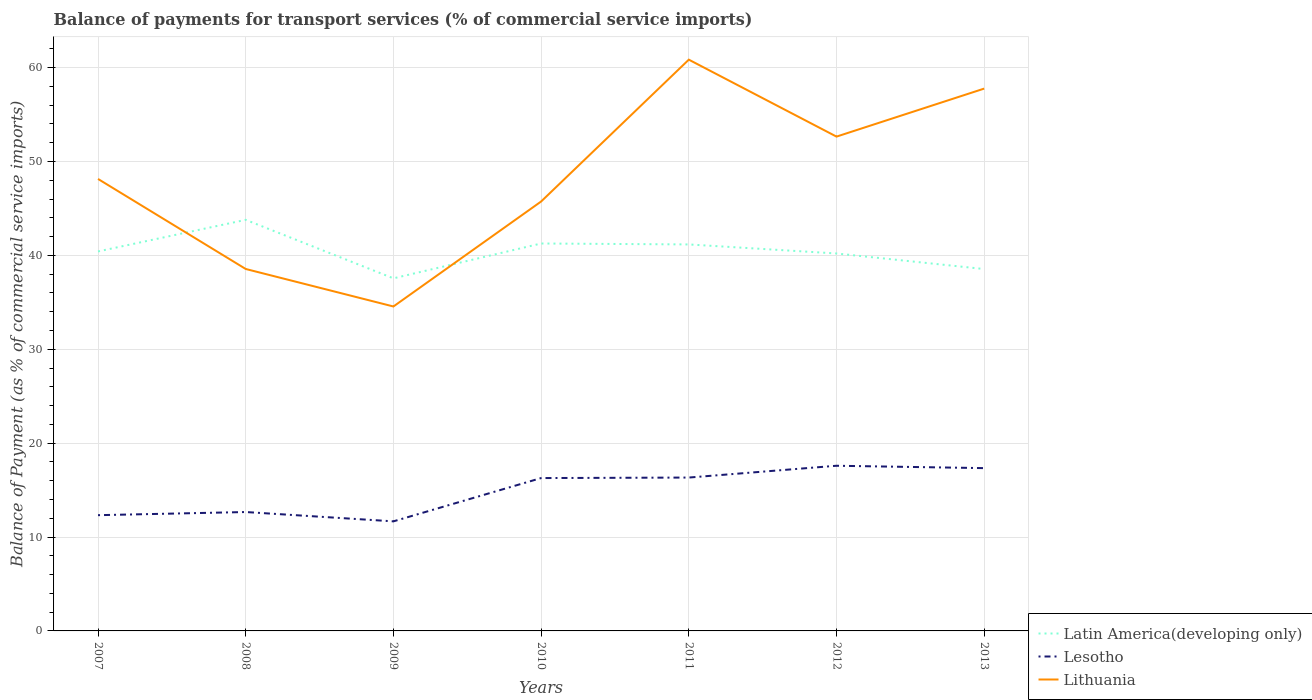How many different coloured lines are there?
Give a very brief answer. 3. Is the number of lines equal to the number of legend labels?
Your answer should be very brief. Yes. Across all years, what is the maximum balance of payments for transport services in Lesotho?
Provide a short and direct response. 11.67. In which year was the balance of payments for transport services in Lithuania maximum?
Provide a short and direct response. 2009. What is the total balance of payments for transport services in Lithuania in the graph?
Offer a terse response. 3.99. What is the difference between the highest and the second highest balance of payments for transport services in Lesotho?
Offer a very short reply. 5.92. How many lines are there?
Your answer should be compact. 3. How many years are there in the graph?
Provide a succinct answer. 7. Are the values on the major ticks of Y-axis written in scientific E-notation?
Keep it short and to the point. No. What is the title of the graph?
Offer a very short reply. Balance of payments for transport services (% of commercial service imports). Does "Gambia, The" appear as one of the legend labels in the graph?
Ensure brevity in your answer.  No. What is the label or title of the X-axis?
Offer a very short reply. Years. What is the label or title of the Y-axis?
Give a very brief answer. Balance of Payment (as % of commercial service imports). What is the Balance of Payment (as % of commercial service imports) in Latin America(developing only) in 2007?
Give a very brief answer. 40.42. What is the Balance of Payment (as % of commercial service imports) in Lesotho in 2007?
Provide a short and direct response. 12.33. What is the Balance of Payment (as % of commercial service imports) of Lithuania in 2007?
Your response must be concise. 48.14. What is the Balance of Payment (as % of commercial service imports) in Latin America(developing only) in 2008?
Your answer should be very brief. 43.79. What is the Balance of Payment (as % of commercial service imports) of Lesotho in 2008?
Offer a terse response. 12.66. What is the Balance of Payment (as % of commercial service imports) in Lithuania in 2008?
Offer a very short reply. 38.55. What is the Balance of Payment (as % of commercial service imports) of Latin America(developing only) in 2009?
Provide a short and direct response. 37.55. What is the Balance of Payment (as % of commercial service imports) of Lesotho in 2009?
Ensure brevity in your answer.  11.67. What is the Balance of Payment (as % of commercial service imports) of Lithuania in 2009?
Offer a very short reply. 34.56. What is the Balance of Payment (as % of commercial service imports) of Latin America(developing only) in 2010?
Make the answer very short. 41.27. What is the Balance of Payment (as % of commercial service imports) of Lesotho in 2010?
Provide a short and direct response. 16.28. What is the Balance of Payment (as % of commercial service imports) in Lithuania in 2010?
Offer a terse response. 45.74. What is the Balance of Payment (as % of commercial service imports) in Latin America(developing only) in 2011?
Your response must be concise. 41.17. What is the Balance of Payment (as % of commercial service imports) of Lesotho in 2011?
Give a very brief answer. 16.34. What is the Balance of Payment (as % of commercial service imports) of Lithuania in 2011?
Provide a succinct answer. 60.85. What is the Balance of Payment (as % of commercial service imports) of Latin America(developing only) in 2012?
Give a very brief answer. 40.2. What is the Balance of Payment (as % of commercial service imports) in Lesotho in 2012?
Give a very brief answer. 17.59. What is the Balance of Payment (as % of commercial service imports) in Lithuania in 2012?
Offer a very short reply. 52.65. What is the Balance of Payment (as % of commercial service imports) of Latin America(developing only) in 2013?
Your answer should be compact. 38.54. What is the Balance of Payment (as % of commercial service imports) of Lesotho in 2013?
Ensure brevity in your answer.  17.34. What is the Balance of Payment (as % of commercial service imports) of Lithuania in 2013?
Keep it short and to the point. 57.77. Across all years, what is the maximum Balance of Payment (as % of commercial service imports) in Latin America(developing only)?
Give a very brief answer. 43.79. Across all years, what is the maximum Balance of Payment (as % of commercial service imports) in Lesotho?
Make the answer very short. 17.59. Across all years, what is the maximum Balance of Payment (as % of commercial service imports) of Lithuania?
Provide a succinct answer. 60.85. Across all years, what is the minimum Balance of Payment (as % of commercial service imports) in Latin America(developing only)?
Give a very brief answer. 37.55. Across all years, what is the minimum Balance of Payment (as % of commercial service imports) of Lesotho?
Make the answer very short. 11.67. Across all years, what is the minimum Balance of Payment (as % of commercial service imports) in Lithuania?
Your response must be concise. 34.56. What is the total Balance of Payment (as % of commercial service imports) of Latin America(developing only) in the graph?
Your answer should be very brief. 282.94. What is the total Balance of Payment (as % of commercial service imports) in Lesotho in the graph?
Offer a terse response. 104.21. What is the total Balance of Payment (as % of commercial service imports) in Lithuania in the graph?
Your answer should be very brief. 338.26. What is the difference between the Balance of Payment (as % of commercial service imports) in Latin America(developing only) in 2007 and that in 2008?
Your answer should be very brief. -3.37. What is the difference between the Balance of Payment (as % of commercial service imports) of Lesotho in 2007 and that in 2008?
Your response must be concise. -0.34. What is the difference between the Balance of Payment (as % of commercial service imports) of Lithuania in 2007 and that in 2008?
Provide a succinct answer. 9.59. What is the difference between the Balance of Payment (as % of commercial service imports) of Latin America(developing only) in 2007 and that in 2009?
Offer a terse response. 2.87. What is the difference between the Balance of Payment (as % of commercial service imports) of Lesotho in 2007 and that in 2009?
Keep it short and to the point. 0.66. What is the difference between the Balance of Payment (as % of commercial service imports) of Lithuania in 2007 and that in 2009?
Your answer should be compact. 13.59. What is the difference between the Balance of Payment (as % of commercial service imports) of Latin America(developing only) in 2007 and that in 2010?
Offer a very short reply. -0.85. What is the difference between the Balance of Payment (as % of commercial service imports) of Lesotho in 2007 and that in 2010?
Give a very brief answer. -3.95. What is the difference between the Balance of Payment (as % of commercial service imports) of Lithuania in 2007 and that in 2010?
Your response must be concise. 2.4. What is the difference between the Balance of Payment (as % of commercial service imports) in Latin America(developing only) in 2007 and that in 2011?
Your answer should be very brief. -0.75. What is the difference between the Balance of Payment (as % of commercial service imports) in Lesotho in 2007 and that in 2011?
Provide a succinct answer. -4.01. What is the difference between the Balance of Payment (as % of commercial service imports) in Lithuania in 2007 and that in 2011?
Keep it short and to the point. -12.71. What is the difference between the Balance of Payment (as % of commercial service imports) in Latin America(developing only) in 2007 and that in 2012?
Your response must be concise. 0.22. What is the difference between the Balance of Payment (as % of commercial service imports) of Lesotho in 2007 and that in 2012?
Your answer should be compact. -5.26. What is the difference between the Balance of Payment (as % of commercial service imports) of Lithuania in 2007 and that in 2012?
Offer a very short reply. -4.51. What is the difference between the Balance of Payment (as % of commercial service imports) in Latin America(developing only) in 2007 and that in 2013?
Provide a short and direct response. 1.88. What is the difference between the Balance of Payment (as % of commercial service imports) of Lesotho in 2007 and that in 2013?
Make the answer very short. -5.01. What is the difference between the Balance of Payment (as % of commercial service imports) of Lithuania in 2007 and that in 2013?
Your response must be concise. -9.62. What is the difference between the Balance of Payment (as % of commercial service imports) in Latin America(developing only) in 2008 and that in 2009?
Provide a succinct answer. 6.23. What is the difference between the Balance of Payment (as % of commercial service imports) in Lesotho in 2008 and that in 2009?
Provide a short and direct response. 0.99. What is the difference between the Balance of Payment (as % of commercial service imports) in Lithuania in 2008 and that in 2009?
Your response must be concise. 3.99. What is the difference between the Balance of Payment (as % of commercial service imports) of Latin America(developing only) in 2008 and that in 2010?
Your answer should be compact. 2.52. What is the difference between the Balance of Payment (as % of commercial service imports) in Lesotho in 2008 and that in 2010?
Make the answer very short. -3.62. What is the difference between the Balance of Payment (as % of commercial service imports) of Lithuania in 2008 and that in 2010?
Offer a terse response. -7.19. What is the difference between the Balance of Payment (as % of commercial service imports) of Latin America(developing only) in 2008 and that in 2011?
Provide a succinct answer. 2.62. What is the difference between the Balance of Payment (as % of commercial service imports) in Lesotho in 2008 and that in 2011?
Provide a short and direct response. -3.67. What is the difference between the Balance of Payment (as % of commercial service imports) in Lithuania in 2008 and that in 2011?
Provide a succinct answer. -22.3. What is the difference between the Balance of Payment (as % of commercial service imports) of Latin America(developing only) in 2008 and that in 2012?
Offer a very short reply. 3.58. What is the difference between the Balance of Payment (as % of commercial service imports) in Lesotho in 2008 and that in 2012?
Make the answer very short. -4.93. What is the difference between the Balance of Payment (as % of commercial service imports) in Lithuania in 2008 and that in 2012?
Offer a very short reply. -14.1. What is the difference between the Balance of Payment (as % of commercial service imports) of Latin America(developing only) in 2008 and that in 2013?
Your answer should be very brief. 5.24. What is the difference between the Balance of Payment (as % of commercial service imports) in Lesotho in 2008 and that in 2013?
Offer a terse response. -4.68. What is the difference between the Balance of Payment (as % of commercial service imports) in Lithuania in 2008 and that in 2013?
Ensure brevity in your answer.  -19.21. What is the difference between the Balance of Payment (as % of commercial service imports) in Latin America(developing only) in 2009 and that in 2010?
Ensure brevity in your answer.  -3.71. What is the difference between the Balance of Payment (as % of commercial service imports) in Lesotho in 2009 and that in 2010?
Your response must be concise. -4.61. What is the difference between the Balance of Payment (as % of commercial service imports) of Lithuania in 2009 and that in 2010?
Keep it short and to the point. -11.18. What is the difference between the Balance of Payment (as % of commercial service imports) in Latin America(developing only) in 2009 and that in 2011?
Ensure brevity in your answer.  -3.61. What is the difference between the Balance of Payment (as % of commercial service imports) in Lesotho in 2009 and that in 2011?
Your response must be concise. -4.67. What is the difference between the Balance of Payment (as % of commercial service imports) in Lithuania in 2009 and that in 2011?
Provide a succinct answer. -26.29. What is the difference between the Balance of Payment (as % of commercial service imports) of Latin America(developing only) in 2009 and that in 2012?
Provide a succinct answer. -2.65. What is the difference between the Balance of Payment (as % of commercial service imports) in Lesotho in 2009 and that in 2012?
Offer a terse response. -5.92. What is the difference between the Balance of Payment (as % of commercial service imports) of Lithuania in 2009 and that in 2012?
Give a very brief answer. -18.09. What is the difference between the Balance of Payment (as % of commercial service imports) in Latin America(developing only) in 2009 and that in 2013?
Offer a terse response. -0.99. What is the difference between the Balance of Payment (as % of commercial service imports) in Lesotho in 2009 and that in 2013?
Your answer should be very brief. -5.67. What is the difference between the Balance of Payment (as % of commercial service imports) of Lithuania in 2009 and that in 2013?
Your answer should be very brief. -23.21. What is the difference between the Balance of Payment (as % of commercial service imports) in Latin America(developing only) in 2010 and that in 2011?
Provide a short and direct response. 0.1. What is the difference between the Balance of Payment (as % of commercial service imports) in Lesotho in 2010 and that in 2011?
Your answer should be compact. -0.05. What is the difference between the Balance of Payment (as % of commercial service imports) in Lithuania in 2010 and that in 2011?
Offer a very short reply. -15.11. What is the difference between the Balance of Payment (as % of commercial service imports) in Latin America(developing only) in 2010 and that in 2012?
Provide a short and direct response. 1.06. What is the difference between the Balance of Payment (as % of commercial service imports) of Lesotho in 2010 and that in 2012?
Offer a very short reply. -1.31. What is the difference between the Balance of Payment (as % of commercial service imports) in Lithuania in 2010 and that in 2012?
Make the answer very short. -6.91. What is the difference between the Balance of Payment (as % of commercial service imports) of Latin America(developing only) in 2010 and that in 2013?
Ensure brevity in your answer.  2.72. What is the difference between the Balance of Payment (as % of commercial service imports) of Lesotho in 2010 and that in 2013?
Keep it short and to the point. -1.06. What is the difference between the Balance of Payment (as % of commercial service imports) of Lithuania in 2010 and that in 2013?
Ensure brevity in your answer.  -12.03. What is the difference between the Balance of Payment (as % of commercial service imports) of Lesotho in 2011 and that in 2012?
Provide a succinct answer. -1.26. What is the difference between the Balance of Payment (as % of commercial service imports) of Lithuania in 2011 and that in 2012?
Your answer should be compact. 8.2. What is the difference between the Balance of Payment (as % of commercial service imports) in Latin America(developing only) in 2011 and that in 2013?
Provide a succinct answer. 2.62. What is the difference between the Balance of Payment (as % of commercial service imports) in Lesotho in 2011 and that in 2013?
Offer a terse response. -1. What is the difference between the Balance of Payment (as % of commercial service imports) in Lithuania in 2011 and that in 2013?
Provide a short and direct response. 3.08. What is the difference between the Balance of Payment (as % of commercial service imports) of Latin America(developing only) in 2012 and that in 2013?
Ensure brevity in your answer.  1.66. What is the difference between the Balance of Payment (as % of commercial service imports) of Lesotho in 2012 and that in 2013?
Provide a short and direct response. 0.25. What is the difference between the Balance of Payment (as % of commercial service imports) of Lithuania in 2012 and that in 2013?
Your answer should be very brief. -5.11. What is the difference between the Balance of Payment (as % of commercial service imports) of Latin America(developing only) in 2007 and the Balance of Payment (as % of commercial service imports) of Lesotho in 2008?
Offer a very short reply. 27.76. What is the difference between the Balance of Payment (as % of commercial service imports) in Latin America(developing only) in 2007 and the Balance of Payment (as % of commercial service imports) in Lithuania in 2008?
Your response must be concise. 1.87. What is the difference between the Balance of Payment (as % of commercial service imports) in Lesotho in 2007 and the Balance of Payment (as % of commercial service imports) in Lithuania in 2008?
Keep it short and to the point. -26.22. What is the difference between the Balance of Payment (as % of commercial service imports) in Latin America(developing only) in 2007 and the Balance of Payment (as % of commercial service imports) in Lesotho in 2009?
Keep it short and to the point. 28.75. What is the difference between the Balance of Payment (as % of commercial service imports) of Latin America(developing only) in 2007 and the Balance of Payment (as % of commercial service imports) of Lithuania in 2009?
Keep it short and to the point. 5.86. What is the difference between the Balance of Payment (as % of commercial service imports) of Lesotho in 2007 and the Balance of Payment (as % of commercial service imports) of Lithuania in 2009?
Give a very brief answer. -22.23. What is the difference between the Balance of Payment (as % of commercial service imports) in Latin America(developing only) in 2007 and the Balance of Payment (as % of commercial service imports) in Lesotho in 2010?
Ensure brevity in your answer.  24.14. What is the difference between the Balance of Payment (as % of commercial service imports) of Latin America(developing only) in 2007 and the Balance of Payment (as % of commercial service imports) of Lithuania in 2010?
Provide a short and direct response. -5.32. What is the difference between the Balance of Payment (as % of commercial service imports) of Lesotho in 2007 and the Balance of Payment (as % of commercial service imports) of Lithuania in 2010?
Ensure brevity in your answer.  -33.41. What is the difference between the Balance of Payment (as % of commercial service imports) of Latin America(developing only) in 2007 and the Balance of Payment (as % of commercial service imports) of Lesotho in 2011?
Provide a succinct answer. 24.08. What is the difference between the Balance of Payment (as % of commercial service imports) in Latin America(developing only) in 2007 and the Balance of Payment (as % of commercial service imports) in Lithuania in 2011?
Make the answer very short. -20.43. What is the difference between the Balance of Payment (as % of commercial service imports) of Lesotho in 2007 and the Balance of Payment (as % of commercial service imports) of Lithuania in 2011?
Offer a very short reply. -48.52. What is the difference between the Balance of Payment (as % of commercial service imports) of Latin America(developing only) in 2007 and the Balance of Payment (as % of commercial service imports) of Lesotho in 2012?
Make the answer very short. 22.83. What is the difference between the Balance of Payment (as % of commercial service imports) in Latin America(developing only) in 2007 and the Balance of Payment (as % of commercial service imports) in Lithuania in 2012?
Keep it short and to the point. -12.23. What is the difference between the Balance of Payment (as % of commercial service imports) of Lesotho in 2007 and the Balance of Payment (as % of commercial service imports) of Lithuania in 2012?
Ensure brevity in your answer.  -40.32. What is the difference between the Balance of Payment (as % of commercial service imports) in Latin America(developing only) in 2007 and the Balance of Payment (as % of commercial service imports) in Lesotho in 2013?
Offer a very short reply. 23.08. What is the difference between the Balance of Payment (as % of commercial service imports) of Latin America(developing only) in 2007 and the Balance of Payment (as % of commercial service imports) of Lithuania in 2013?
Keep it short and to the point. -17.35. What is the difference between the Balance of Payment (as % of commercial service imports) of Lesotho in 2007 and the Balance of Payment (as % of commercial service imports) of Lithuania in 2013?
Ensure brevity in your answer.  -45.44. What is the difference between the Balance of Payment (as % of commercial service imports) in Latin America(developing only) in 2008 and the Balance of Payment (as % of commercial service imports) in Lesotho in 2009?
Provide a short and direct response. 32.12. What is the difference between the Balance of Payment (as % of commercial service imports) in Latin America(developing only) in 2008 and the Balance of Payment (as % of commercial service imports) in Lithuania in 2009?
Ensure brevity in your answer.  9.23. What is the difference between the Balance of Payment (as % of commercial service imports) in Lesotho in 2008 and the Balance of Payment (as % of commercial service imports) in Lithuania in 2009?
Give a very brief answer. -21.89. What is the difference between the Balance of Payment (as % of commercial service imports) in Latin America(developing only) in 2008 and the Balance of Payment (as % of commercial service imports) in Lesotho in 2010?
Your answer should be very brief. 27.5. What is the difference between the Balance of Payment (as % of commercial service imports) in Latin America(developing only) in 2008 and the Balance of Payment (as % of commercial service imports) in Lithuania in 2010?
Your response must be concise. -1.95. What is the difference between the Balance of Payment (as % of commercial service imports) in Lesotho in 2008 and the Balance of Payment (as % of commercial service imports) in Lithuania in 2010?
Keep it short and to the point. -33.08. What is the difference between the Balance of Payment (as % of commercial service imports) in Latin America(developing only) in 2008 and the Balance of Payment (as % of commercial service imports) in Lesotho in 2011?
Your answer should be very brief. 27.45. What is the difference between the Balance of Payment (as % of commercial service imports) in Latin America(developing only) in 2008 and the Balance of Payment (as % of commercial service imports) in Lithuania in 2011?
Provide a short and direct response. -17.06. What is the difference between the Balance of Payment (as % of commercial service imports) in Lesotho in 2008 and the Balance of Payment (as % of commercial service imports) in Lithuania in 2011?
Your answer should be very brief. -48.18. What is the difference between the Balance of Payment (as % of commercial service imports) of Latin America(developing only) in 2008 and the Balance of Payment (as % of commercial service imports) of Lesotho in 2012?
Provide a succinct answer. 26.19. What is the difference between the Balance of Payment (as % of commercial service imports) in Latin America(developing only) in 2008 and the Balance of Payment (as % of commercial service imports) in Lithuania in 2012?
Your answer should be very brief. -8.87. What is the difference between the Balance of Payment (as % of commercial service imports) of Lesotho in 2008 and the Balance of Payment (as % of commercial service imports) of Lithuania in 2012?
Give a very brief answer. -39.99. What is the difference between the Balance of Payment (as % of commercial service imports) of Latin America(developing only) in 2008 and the Balance of Payment (as % of commercial service imports) of Lesotho in 2013?
Your response must be concise. 26.45. What is the difference between the Balance of Payment (as % of commercial service imports) in Latin America(developing only) in 2008 and the Balance of Payment (as % of commercial service imports) in Lithuania in 2013?
Offer a terse response. -13.98. What is the difference between the Balance of Payment (as % of commercial service imports) in Lesotho in 2008 and the Balance of Payment (as % of commercial service imports) in Lithuania in 2013?
Your answer should be very brief. -45.1. What is the difference between the Balance of Payment (as % of commercial service imports) in Latin America(developing only) in 2009 and the Balance of Payment (as % of commercial service imports) in Lesotho in 2010?
Provide a succinct answer. 21.27. What is the difference between the Balance of Payment (as % of commercial service imports) in Latin America(developing only) in 2009 and the Balance of Payment (as % of commercial service imports) in Lithuania in 2010?
Make the answer very short. -8.18. What is the difference between the Balance of Payment (as % of commercial service imports) in Lesotho in 2009 and the Balance of Payment (as % of commercial service imports) in Lithuania in 2010?
Offer a very short reply. -34.07. What is the difference between the Balance of Payment (as % of commercial service imports) of Latin America(developing only) in 2009 and the Balance of Payment (as % of commercial service imports) of Lesotho in 2011?
Provide a succinct answer. 21.22. What is the difference between the Balance of Payment (as % of commercial service imports) of Latin America(developing only) in 2009 and the Balance of Payment (as % of commercial service imports) of Lithuania in 2011?
Offer a very short reply. -23.29. What is the difference between the Balance of Payment (as % of commercial service imports) in Lesotho in 2009 and the Balance of Payment (as % of commercial service imports) in Lithuania in 2011?
Provide a short and direct response. -49.18. What is the difference between the Balance of Payment (as % of commercial service imports) in Latin America(developing only) in 2009 and the Balance of Payment (as % of commercial service imports) in Lesotho in 2012?
Provide a succinct answer. 19.96. What is the difference between the Balance of Payment (as % of commercial service imports) of Latin America(developing only) in 2009 and the Balance of Payment (as % of commercial service imports) of Lithuania in 2012?
Offer a very short reply. -15.1. What is the difference between the Balance of Payment (as % of commercial service imports) in Lesotho in 2009 and the Balance of Payment (as % of commercial service imports) in Lithuania in 2012?
Your answer should be compact. -40.98. What is the difference between the Balance of Payment (as % of commercial service imports) in Latin America(developing only) in 2009 and the Balance of Payment (as % of commercial service imports) in Lesotho in 2013?
Your response must be concise. 20.21. What is the difference between the Balance of Payment (as % of commercial service imports) in Latin America(developing only) in 2009 and the Balance of Payment (as % of commercial service imports) in Lithuania in 2013?
Make the answer very short. -20.21. What is the difference between the Balance of Payment (as % of commercial service imports) in Lesotho in 2009 and the Balance of Payment (as % of commercial service imports) in Lithuania in 2013?
Your answer should be very brief. -46.1. What is the difference between the Balance of Payment (as % of commercial service imports) in Latin America(developing only) in 2010 and the Balance of Payment (as % of commercial service imports) in Lesotho in 2011?
Keep it short and to the point. 24.93. What is the difference between the Balance of Payment (as % of commercial service imports) in Latin America(developing only) in 2010 and the Balance of Payment (as % of commercial service imports) in Lithuania in 2011?
Offer a terse response. -19.58. What is the difference between the Balance of Payment (as % of commercial service imports) of Lesotho in 2010 and the Balance of Payment (as % of commercial service imports) of Lithuania in 2011?
Offer a very short reply. -44.57. What is the difference between the Balance of Payment (as % of commercial service imports) of Latin America(developing only) in 2010 and the Balance of Payment (as % of commercial service imports) of Lesotho in 2012?
Provide a short and direct response. 23.67. What is the difference between the Balance of Payment (as % of commercial service imports) in Latin America(developing only) in 2010 and the Balance of Payment (as % of commercial service imports) in Lithuania in 2012?
Your response must be concise. -11.38. What is the difference between the Balance of Payment (as % of commercial service imports) in Lesotho in 2010 and the Balance of Payment (as % of commercial service imports) in Lithuania in 2012?
Provide a succinct answer. -36.37. What is the difference between the Balance of Payment (as % of commercial service imports) of Latin America(developing only) in 2010 and the Balance of Payment (as % of commercial service imports) of Lesotho in 2013?
Your answer should be compact. 23.93. What is the difference between the Balance of Payment (as % of commercial service imports) in Latin America(developing only) in 2010 and the Balance of Payment (as % of commercial service imports) in Lithuania in 2013?
Make the answer very short. -16.5. What is the difference between the Balance of Payment (as % of commercial service imports) in Lesotho in 2010 and the Balance of Payment (as % of commercial service imports) in Lithuania in 2013?
Make the answer very short. -41.48. What is the difference between the Balance of Payment (as % of commercial service imports) in Latin America(developing only) in 2011 and the Balance of Payment (as % of commercial service imports) in Lesotho in 2012?
Offer a terse response. 23.57. What is the difference between the Balance of Payment (as % of commercial service imports) of Latin America(developing only) in 2011 and the Balance of Payment (as % of commercial service imports) of Lithuania in 2012?
Your response must be concise. -11.49. What is the difference between the Balance of Payment (as % of commercial service imports) in Lesotho in 2011 and the Balance of Payment (as % of commercial service imports) in Lithuania in 2012?
Your response must be concise. -36.32. What is the difference between the Balance of Payment (as % of commercial service imports) in Latin America(developing only) in 2011 and the Balance of Payment (as % of commercial service imports) in Lesotho in 2013?
Keep it short and to the point. 23.83. What is the difference between the Balance of Payment (as % of commercial service imports) of Latin America(developing only) in 2011 and the Balance of Payment (as % of commercial service imports) of Lithuania in 2013?
Your answer should be compact. -16.6. What is the difference between the Balance of Payment (as % of commercial service imports) of Lesotho in 2011 and the Balance of Payment (as % of commercial service imports) of Lithuania in 2013?
Make the answer very short. -41.43. What is the difference between the Balance of Payment (as % of commercial service imports) of Latin America(developing only) in 2012 and the Balance of Payment (as % of commercial service imports) of Lesotho in 2013?
Provide a short and direct response. 22.86. What is the difference between the Balance of Payment (as % of commercial service imports) of Latin America(developing only) in 2012 and the Balance of Payment (as % of commercial service imports) of Lithuania in 2013?
Ensure brevity in your answer.  -17.56. What is the difference between the Balance of Payment (as % of commercial service imports) in Lesotho in 2012 and the Balance of Payment (as % of commercial service imports) in Lithuania in 2013?
Give a very brief answer. -40.17. What is the average Balance of Payment (as % of commercial service imports) of Latin America(developing only) per year?
Offer a terse response. 40.42. What is the average Balance of Payment (as % of commercial service imports) in Lesotho per year?
Provide a short and direct response. 14.89. What is the average Balance of Payment (as % of commercial service imports) of Lithuania per year?
Offer a terse response. 48.32. In the year 2007, what is the difference between the Balance of Payment (as % of commercial service imports) of Latin America(developing only) and Balance of Payment (as % of commercial service imports) of Lesotho?
Provide a succinct answer. 28.09. In the year 2007, what is the difference between the Balance of Payment (as % of commercial service imports) of Latin America(developing only) and Balance of Payment (as % of commercial service imports) of Lithuania?
Give a very brief answer. -7.72. In the year 2007, what is the difference between the Balance of Payment (as % of commercial service imports) of Lesotho and Balance of Payment (as % of commercial service imports) of Lithuania?
Make the answer very short. -35.81. In the year 2008, what is the difference between the Balance of Payment (as % of commercial service imports) in Latin America(developing only) and Balance of Payment (as % of commercial service imports) in Lesotho?
Your answer should be very brief. 31.12. In the year 2008, what is the difference between the Balance of Payment (as % of commercial service imports) in Latin America(developing only) and Balance of Payment (as % of commercial service imports) in Lithuania?
Make the answer very short. 5.23. In the year 2008, what is the difference between the Balance of Payment (as % of commercial service imports) of Lesotho and Balance of Payment (as % of commercial service imports) of Lithuania?
Provide a succinct answer. -25.89. In the year 2009, what is the difference between the Balance of Payment (as % of commercial service imports) in Latin America(developing only) and Balance of Payment (as % of commercial service imports) in Lesotho?
Give a very brief answer. 25.88. In the year 2009, what is the difference between the Balance of Payment (as % of commercial service imports) of Latin America(developing only) and Balance of Payment (as % of commercial service imports) of Lithuania?
Your response must be concise. 3. In the year 2009, what is the difference between the Balance of Payment (as % of commercial service imports) in Lesotho and Balance of Payment (as % of commercial service imports) in Lithuania?
Provide a succinct answer. -22.89. In the year 2010, what is the difference between the Balance of Payment (as % of commercial service imports) in Latin America(developing only) and Balance of Payment (as % of commercial service imports) in Lesotho?
Offer a very short reply. 24.99. In the year 2010, what is the difference between the Balance of Payment (as % of commercial service imports) in Latin America(developing only) and Balance of Payment (as % of commercial service imports) in Lithuania?
Make the answer very short. -4.47. In the year 2010, what is the difference between the Balance of Payment (as % of commercial service imports) of Lesotho and Balance of Payment (as % of commercial service imports) of Lithuania?
Provide a succinct answer. -29.46. In the year 2011, what is the difference between the Balance of Payment (as % of commercial service imports) of Latin America(developing only) and Balance of Payment (as % of commercial service imports) of Lesotho?
Provide a succinct answer. 24.83. In the year 2011, what is the difference between the Balance of Payment (as % of commercial service imports) of Latin America(developing only) and Balance of Payment (as % of commercial service imports) of Lithuania?
Offer a terse response. -19.68. In the year 2011, what is the difference between the Balance of Payment (as % of commercial service imports) of Lesotho and Balance of Payment (as % of commercial service imports) of Lithuania?
Provide a short and direct response. -44.51. In the year 2012, what is the difference between the Balance of Payment (as % of commercial service imports) in Latin America(developing only) and Balance of Payment (as % of commercial service imports) in Lesotho?
Your response must be concise. 22.61. In the year 2012, what is the difference between the Balance of Payment (as % of commercial service imports) of Latin America(developing only) and Balance of Payment (as % of commercial service imports) of Lithuania?
Ensure brevity in your answer.  -12.45. In the year 2012, what is the difference between the Balance of Payment (as % of commercial service imports) in Lesotho and Balance of Payment (as % of commercial service imports) in Lithuania?
Provide a succinct answer. -35.06. In the year 2013, what is the difference between the Balance of Payment (as % of commercial service imports) of Latin America(developing only) and Balance of Payment (as % of commercial service imports) of Lesotho?
Provide a succinct answer. 21.2. In the year 2013, what is the difference between the Balance of Payment (as % of commercial service imports) of Latin America(developing only) and Balance of Payment (as % of commercial service imports) of Lithuania?
Offer a terse response. -19.22. In the year 2013, what is the difference between the Balance of Payment (as % of commercial service imports) in Lesotho and Balance of Payment (as % of commercial service imports) in Lithuania?
Give a very brief answer. -40.43. What is the ratio of the Balance of Payment (as % of commercial service imports) in Lesotho in 2007 to that in 2008?
Ensure brevity in your answer.  0.97. What is the ratio of the Balance of Payment (as % of commercial service imports) of Lithuania in 2007 to that in 2008?
Make the answer very short. 1.25. What is the ratio of the Balance of Payment (as % of commercial service imports) of Latin America(developing only) in 2007 to that in 2009?
Provide a short and direct response. 1.08. What is the ratio of the Balance of Payment (as % of commercial service imports) in Lesotho in 2007 to that in 2009?
Keep it short and to the point. 1.06. What is the ratio of the Balance of Payment (as % of commercial service imports) in Lithuania in 2007 to that in 2009?
Your answer should be very brief. 1.39. What is the ratio of the Balance of Payment (as % of commercial service imports) in Latin America(developing only) in 2007 to that in 2010?
Keep it short and to the point. 0.98. What is the ratio of the Balance of Payment (as % of commercial service imports) of Lesotho in 2007 to that in 2010?
Offer a terse response. 0.76. What is the ratio of the Balance of Payment (as % of commercial service imports) in Lithuania in 2007 to that in 2010?
Keep it short and to the point. 1.05. What is the ratio of the Balance of Payment (as % of commercial service imports) in Latin America(developing only) in 2007 to that in 2011?
Offer a terse response. 0.98. What is the ratio of the Balance of Payment (as % of commercial service imports) in Lesotho in 2007 to that in 2011?
Provide a short and direct response. 0.75. What is the ratio of the Balance of Payment (as % of commercial service imports) of Lithuania in 2007 to that in 2011?
Provide a short and direct response. 0.79. What is the ratio of the Balance of Payment (as % of commercial service imports) in Latin America(developing only) in 2007 to that in 2012?
Offer a very short reply. 1.01. What is the ratio of the Balance of Payment (as % of commercial service imports) in Lesotho in 2007 to that in 2012?
Offer a very short reply. 0.7. What is the ratio of the Balance of Payment (as % of commercial service imports) in Lithuania in 2007 to that in 2012?
Your response must be concise. 0.91. What is the ratio of the Balance of Payment (as % of commercial service imports) in Latin America(developing only) in 2007 to that in 2013?
Offer a terse response. 1.05. What is the ratio of the Balance of Payment (as % of commercial service imports) of Lesotho in 2007 to that in 2013?
Provide a succinct answer. 0.71. What is the ratio of the Balance of Payment (as % of commercial service imports) in Lithuania in 2007 to that in 2013?
Your answer should be compact. 0.83. What is the ratio of the Balance of Payment (as % of commercial service imports) in Latin America(developing only) in 2008 to that in 2009?
Provide a short and direct response. 1.17. What is the ratio of the Balance of Payment (as % of commercial service imports) of Lesotho in 2008 to that in 2009?
Give a very brief answer. 1.09. What is the ratio of the Balance of Payment (as % of commercial service imports) in Lithuania in 2008 to that in 2009?
Your answer should be very brief. 1.12. What is the ratio of the Balance of Payment (as % of commercial service imports) of Latin America(developing only) in 2008 to that in 2010?
Provide a short and direct response. 1.06. What is the ratio of the Balance of Payment (as % of commercial service imports) of Lesotho in 2008 to that in 2010?
Give a very brief answer. 0.78. What is the ratio of the Balance of Payment (as % of commercial service imports) in Lithuania in 2008 to that in 2010?
Keep it short and to the point. 0.84. What is the ratio of the Balance of Payment (as % of commercial service imports) of Latin America(developing only) in 2008 to that in 2011?
Give a very brief answer. 1.06. What is the ratio of the Balance of Payment (as % of commercial service imports) in Lesotho in 2008 to that in 2011?
Your answer should be very brief. 0.78. What is the ratio of the Balance of Payment (as % of commercial service imports) of Lithuania in 2008 to that in 2011?
Your answer should be compact. 0.63. What is the ratio of the Balance of Payment (as % of commercial service imports) of Latin America(developing only) in 2008 to that in 2012?
Make the answer very short. 1.09. What is the ratio of the Balance of Payment (as % of commercial service imports) in Lesotho in 2008 to that in 2012?
Give a very brief answer. 0.72. What is the ratio of the Balance of Payment (as % of commercial service imports) in Lithuania in 2008 to that in 2012?
Ensure brevity in your answer.  0.73. What is the ratio of the Balance of Payment (as % of commercial service imports) of Latin America(developing only) in 2008 to that in 2013?
Your response must be concise. 1.14. What is the ratio of the Balance of Payment (as % of commercial service imports) in Lesotho in 2008 to that in 2013?
Your response must be concise. 0.73. What is the ratio of the Balance of Payment (as % of commercial service imports) of Lithuania in 2008 to that in 2013?
Provide a short and direct response. 0.67. What is the ratio of the Balance of Payment (as % of commercial service imports) in Latin America(developing only) in 2009 to that in 2010?
Your answer should be compact. 0.91. What is the ratio of the Balance of Payment (as % of commercial service imports) in Lesotho in 2009 to that in 2010?
Ensure brevity in your answer.  0.72. What is the ratio of the Balance of Payment (as % of commercial service imports) in Lithuania in 2009 to that in 2010?
Your response must be concise. 0.76. What is the ratio of the Balance of Payment (as % of commercial service imports) in Latin America(developing only) in 2009 to that in 2011?
Provide a short and direct response. 0.91. What is the ratio of the Balance of Payment (as % of commercial service imports) of Lesotho in 2009 to that in 2011?
Provide a short and direct response. 0.71. What is the ratio of the Balance of Payment (as % of commercial service imports) in Lithuania in 2009 to that in 2011?
Offer a very short reply. 0.57. What is the ratio of the Balance of Payment (as % of commercial service imports) of Latin America(developing only) in 2009 to that in 2012?
Your response must be concise. 0.93. What is the ratio of the Balance of Payment (as % of commercial service imports) of Lesotho in 2009 to that in 2012?
Your answer should be compact. 0.66. What is the ratio of the Balance of Payment (as % of commercial service imports) in Lithuania in 2009 to that in 2012?
Keep it short and to the point. 0.66. What is the ratio of the Balance of Payment (as % of commercial service imports) of Latin America(developing only) in 2009 to that in 2013?
Your response must be concise. 0.97. What is the ratio of the Balance of Payment (as % of commercial service imports) in Lesotho in 2009 to that in 2013?
Make the answer very short. 0.67. What is the ratio of the Balance of Payment (as % of commercial service imports) of Lithuania in 2009 to that in 2013?
Keep it short and to the point. 0.6. What is the ratio of the Balance of Payment (as % of commercial service imports) of Lesotho in 2010 to that in 2011?
Your answer should be very brief. 1. What is the ratio of the Balance of Payment (as % of commercial service imports) in Lithuania in 2010 to that in 2011?
Provide a succinct answer. 0.75. What is the ratio of the Balance of Payment (as % of commercial service imports) in Latin America(developing only) in 2010 to that in 2012?
Ensure brevity in your answer.  1.03. What is the ratio of the Balance of Payment (as % of commercial service imports) in Lesotho in 2010 to that in 2012?
Give a very brief answer. 0.93. What is the ratio of the Balance of Payment (as % of commercial service imports) in Lithuania in 2010 to that in 2012?
Make the answer very short. 0.87. What is the ratio of the Balance of Payment (as % of commercial service imports) of Latin America(developing only) in 2010 to that in 2013?
Your response must be concise. 1.07. What is the ratio of the Balance of Payment (as % of commercial service imports) in Lesotho in 2010 to that in 2013?
Make the answer very short. 0.94. What is the ratio of the Balance of Payment (as % of commercial service imports) in Lithuania in 2010 to that in 2013?
Provide a short and direct response. 0.79. What is the ratio of the Balance of Payment (as % of commercial service imports) of Latin America(developing only) in 2011 to that in 2012?
Make the answer very short. 1.02. What is the ratio of the Balance of Payment (as % of commercial service imports) of Lithuania in 2011 to that in 2012?
Provide a succinct answer. 1.16. What is the ratio of the Balance of Payment (as % of commercial service imports) in Latin America(developing only) in 2011 to that in 2013?
Your response must be concise. 1.07. What is the ratio of the Balance of Payment (as % of commercial service imports) of Lesotho in 2011 to that in 2013?
Give a very brief answer. 0.94. What is the ratio of the Balance of Payment (as % of commercial service imports) in Lithuania in 2011 to that in 2013?
Ensure brevity in your answer.  1.05. What is the ratio of the Balance of Payment (as % of commercial service imports) of Latin America(developing only) in 2012 to that in 2013?
Make the answer very short. 1.04. What is the ratio of the Balance of Payment (as % of commercial service imports) in Lesotho in 2012 to that in 2013?
Offer a very short reply. 1.01. What is the ratio of the Balance of Payment (as % of commercial service imports) of Lithuania in 2012 to that in 2013?
Your response must be concise. 0.91. What is the difference between the highest and the second highest Balance of Payment (as % of commercial service imports) of Latin America(developing only)?
Offer a terse response. 2.52. What is the difference between the highest and the second highest Balance of Payment (as % of commercial service imports) of Lesotho?
Your answer should be compact. 0.25. What is the difference between the highest and the second highest Balance of Payment (as % of commercial service imports) in Lithuania?
Your answer should be compact. 3.08. What is the difference between the highest and the lowest Balance of Payment (as % of commercial service imports) of Latin America(developing only)?
Offer a very short reply. 6.23. What is the difference between the highest and the lowest Balance of Payment (as % of commercial service imports) of Lesotho?
Keep it short and to the point. 5.92. What is the difference between the highest and the lowest Balance of Payment (as % of commercial service imports) of Lithuania?
Ensure brevity in your answer.  26.29. 